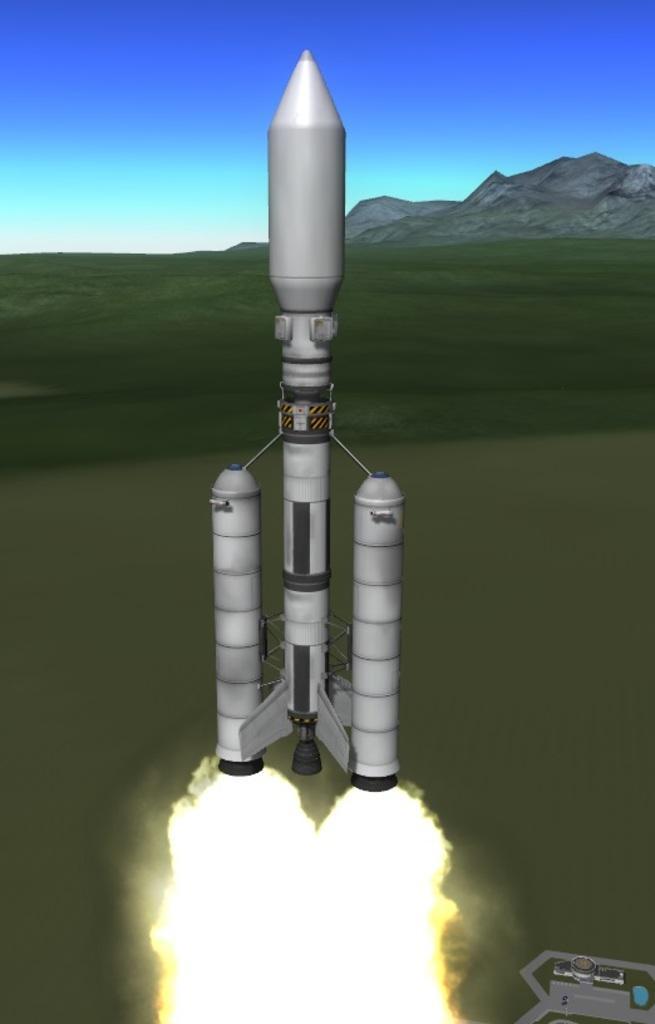Could you give a brief overview of what you see in this image? This is an animated image in which there is a rocket in the front and in the background there is grass and there are mountains. 